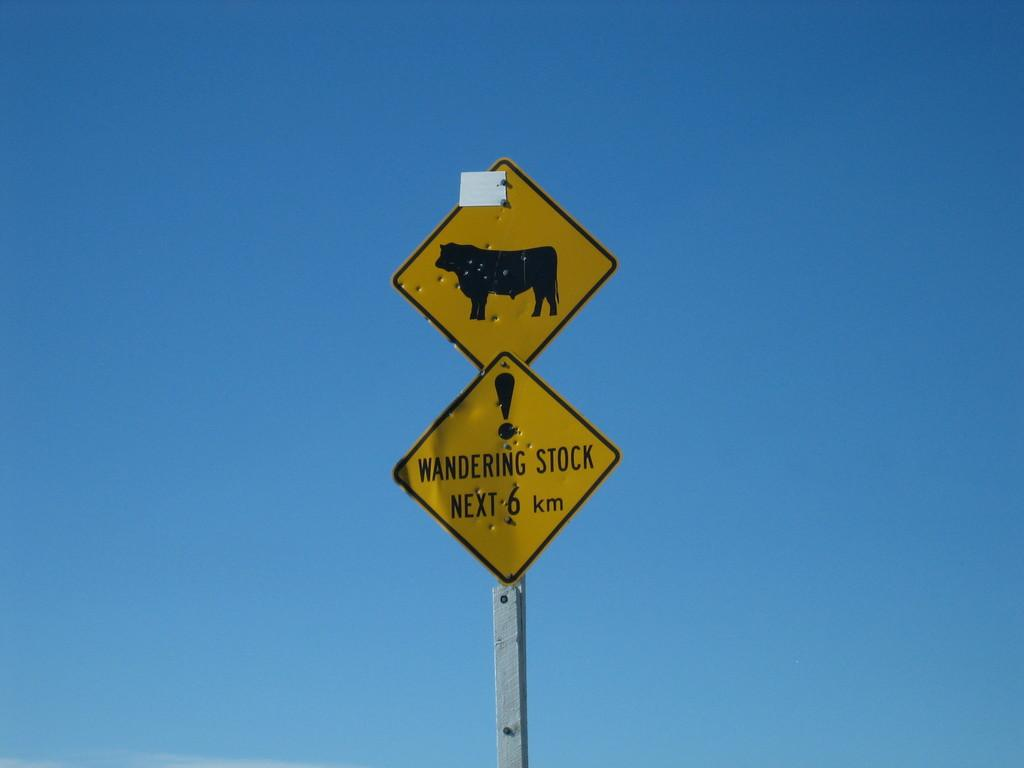What is the main object in the image? There is a pole in the image. What is attached to the pole? There are two yellow-colored boards on the pole. Can you read what is written on one of the boards? Unfortunately, the content of the writing cannot be determined from the image. What is the color of the background in the image? The background color is blue. What type of yam is being measured on the pole in the image? There is no yam or measuring device present in the image. What type of jeans are hanging on the pole in the image? There are no jeans present in the image. 